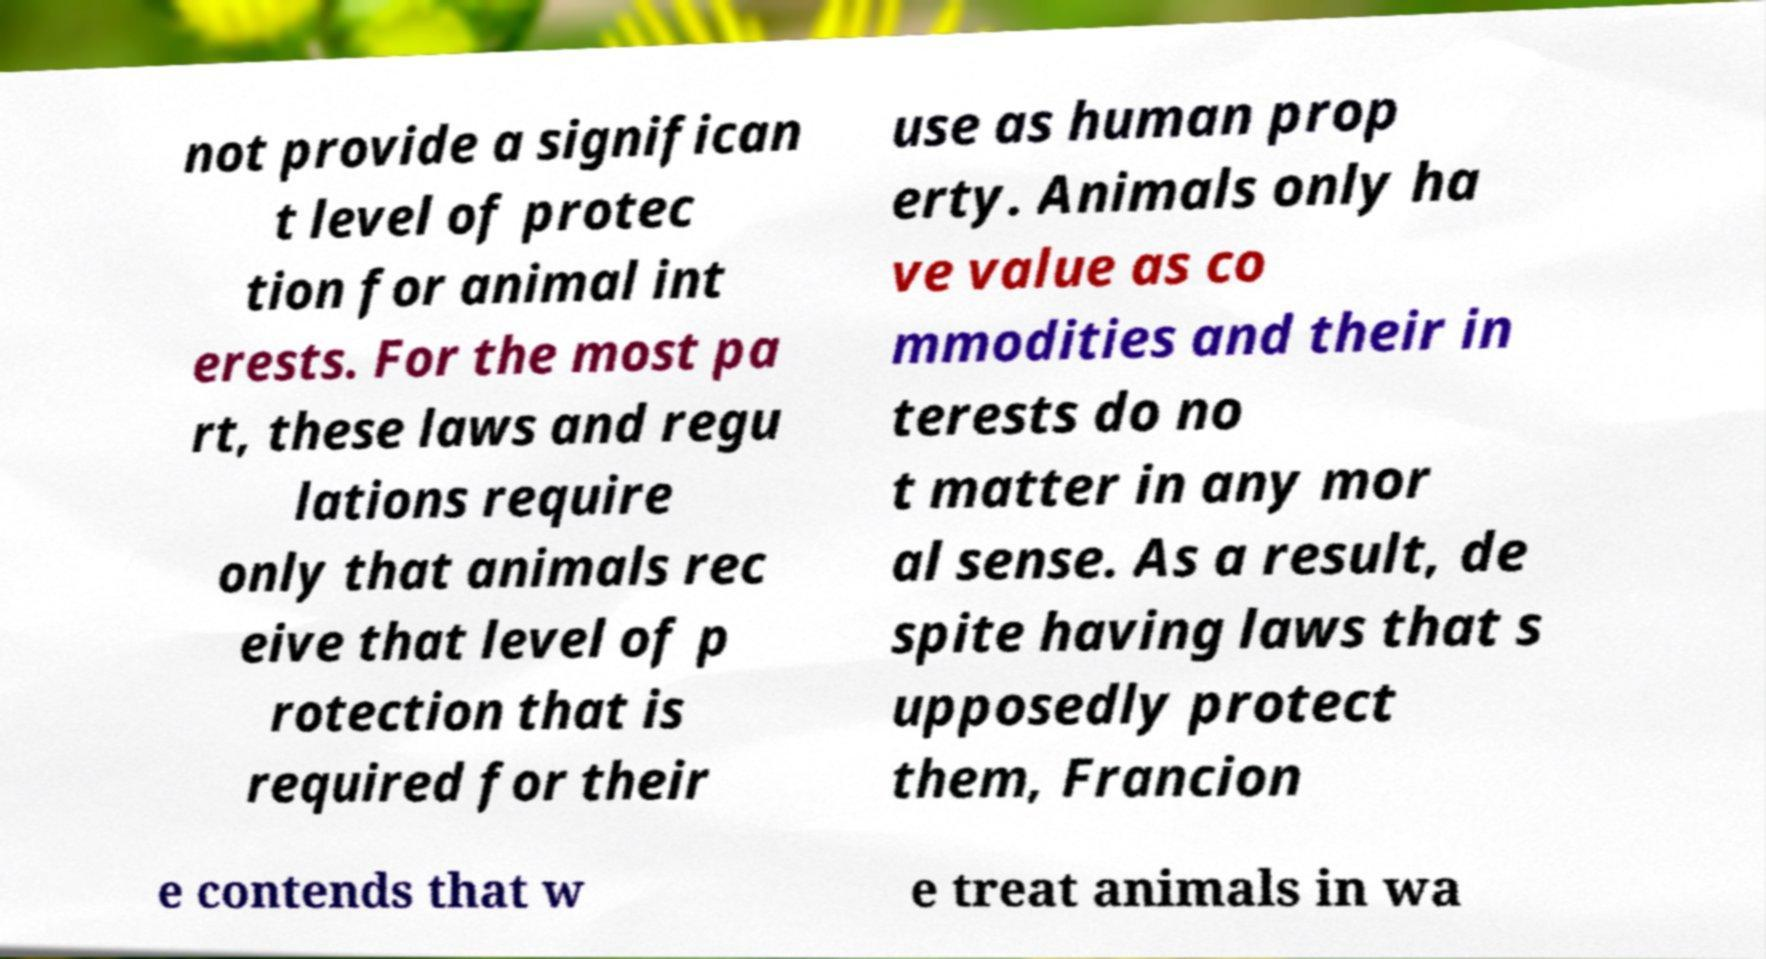Could you extract and type out the text from this image? not provide a significan t level of protec tion for animal int erests. For the most pa rt, these laws and regu lations require only that animals rec eive that level of p rotection that is required for their use as human prop erty. Animals only ha ve value as co mmodities and their in terests do no t matter in any mor al sense. As a result, de spite having laws that s upposedly protect them, Francion e contends that w e treat animals in wa 